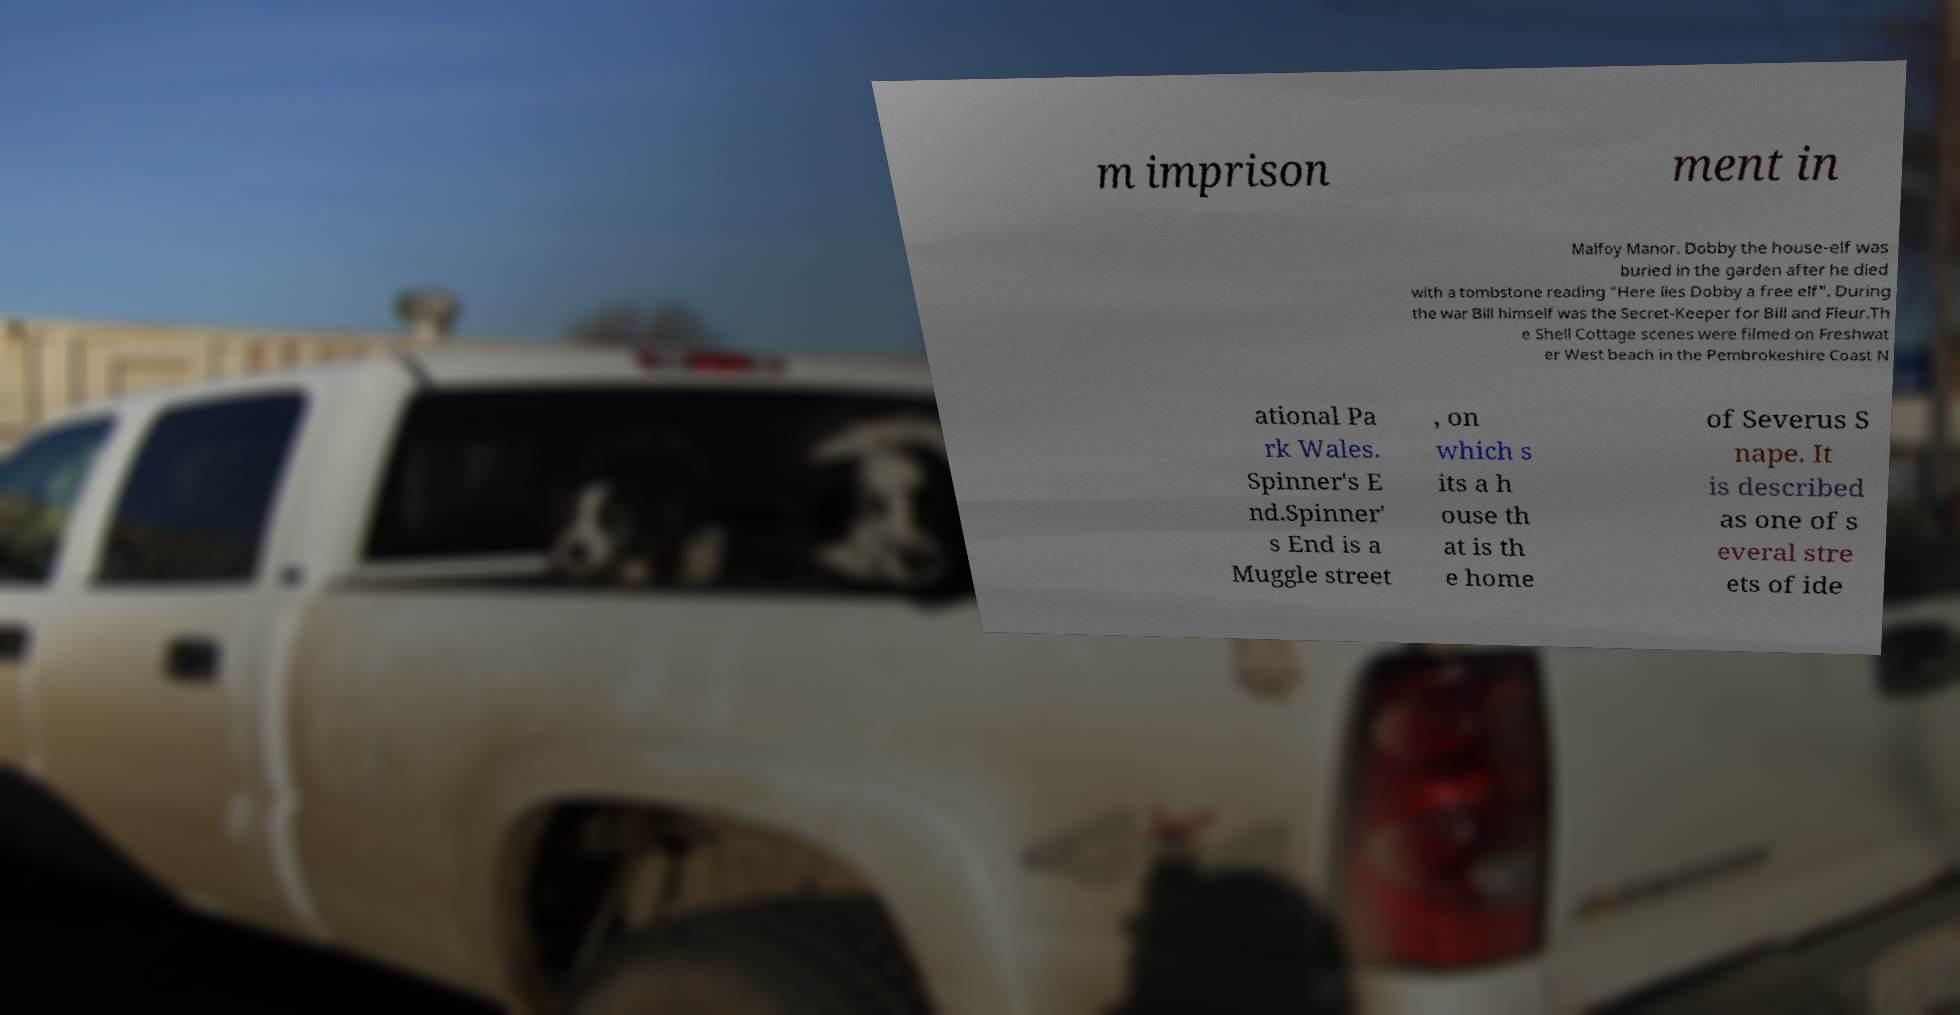I need the written content from this picture converted into text. Can you do that? m imprison ment in Malfoy Manor. Dobby the house-elf was buried in the garden after he died with a tombstone reading "Here lies Dobby a free elf". During the war Bill himself was the Secret-Keeper for Bill and Fleur.Th e Shell Cottage scenes were filmed on Freshwat er West beach in the Pembrokeshire Coast N ational Pa rk Wales. Spinner's E nd.Spinner' s End is a Muggle street , on which s its a h ouse th at is th e home of Severus S nape. It is described as one of s everal stre ets of ide 